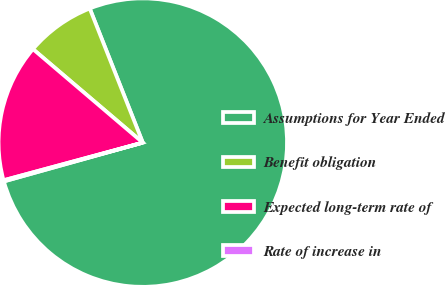Convert chart to OTSL. <chart><loc_0><loc_0><loc_500><loc_500><pie_chart><fcel>Assumptions for Year Ended<fcel>Benefit obligation<fcel>Expected long-term rate of<fcel>Rate of increase in<nl><fcel>76.65%<fcel>7.78%<fcel>15.43%<fcel>0.13%<nl></chart> 